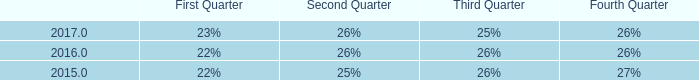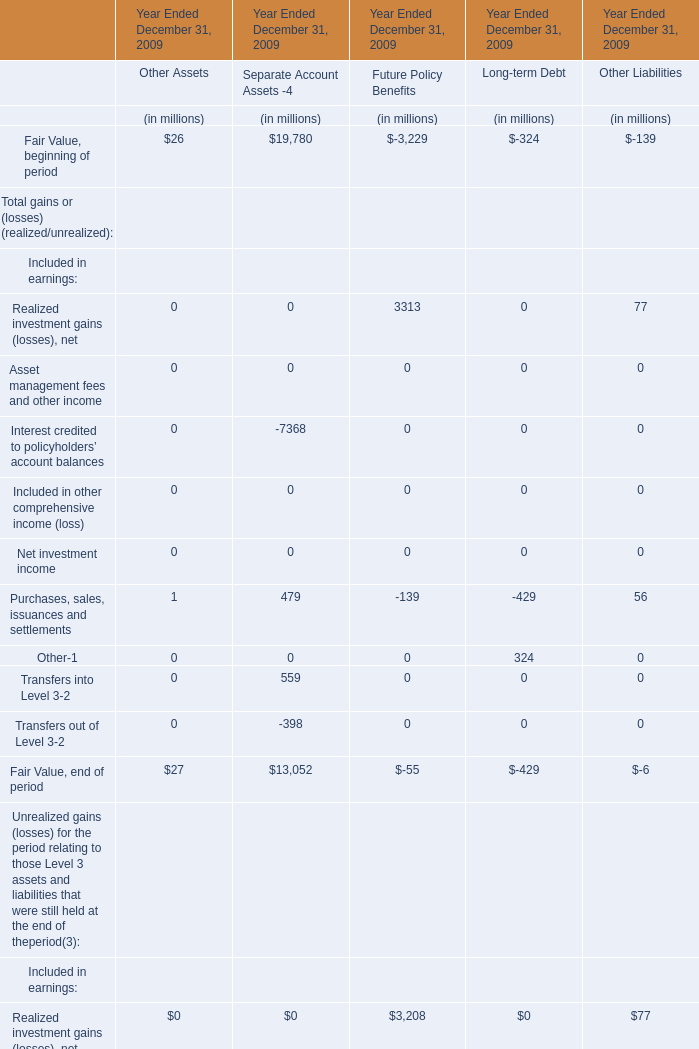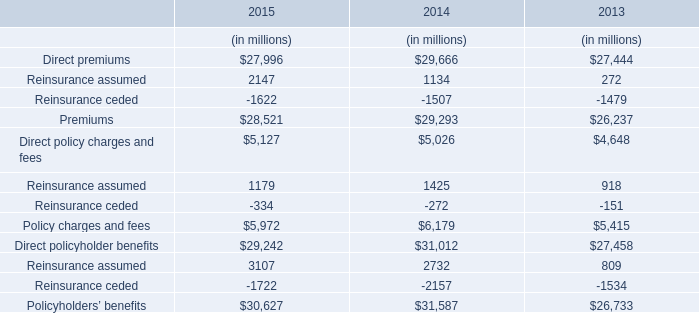What's the 50 % of the sum of the Total gains (realized/unrealized) Included in earnings:Realized investment gains, net in the Year Ended December 31, 2009? (in million) 
Computations: (0.5 * (3313 + 77))
Answer: 1695.0. 